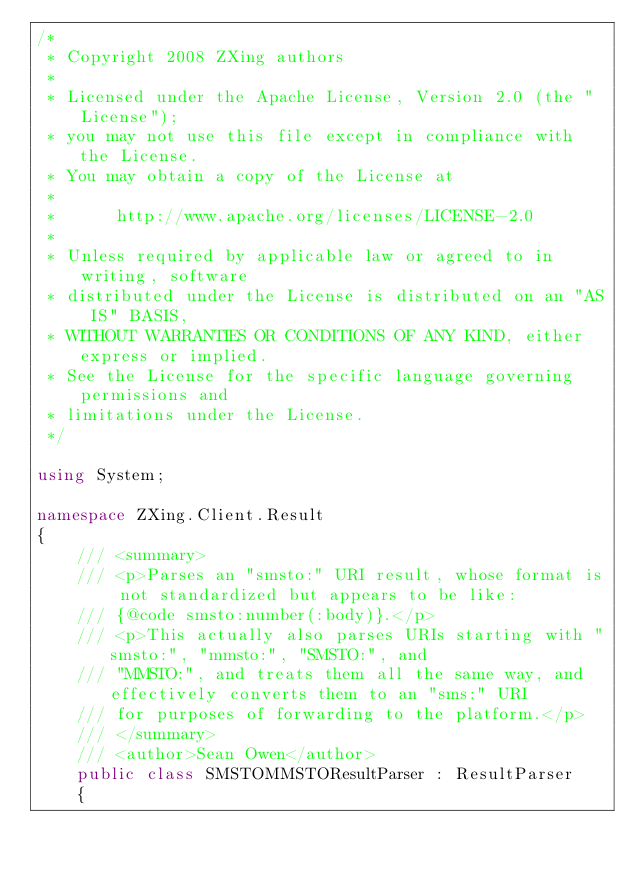Convert code to text. <code><loc_0><loc_0><loc_500><loc_500><_C#_>/*
 * Copyright 2008 ZXing authors
 *
 * Licensed under the Apache License, Version 2.0 (the "License");
 * you may not use this file except in compliance with the License.
 * You may obtain a copy of the License at
 *
 *      http://www.apache.org/licenses/LICENSE-2.0
 *
 * Unless required by applicable law or agreed to in writing, software
 * distributed under the License is distributed on an "AS IS" BASIS,
 * WITHOUT WARRANTIES OR CONDITIONS OF ANY KIND, either express or implied.
 * See the License for the specific language governing permissions and
 * limitations under the License.
 */

using System;

namespace ZXing.Client.Result
{
    /// <summary>
    /// <p>Parses an "smsto:" URI result, whose format is not standardized but appears to be like:
    /// {@code smsto:number(:body)}.</p>
    /// <p>This actually also parses URIs starting with "smsto:", "mmsto:", "SMSTO:", and
    /// "MMSTO:", and treats them all the same way, and effectively converts them to an "sms:" URI
    /// for purposes of forwarding to the platform.</p>
    /// </summary>
    /// <author>Sean Owen</author>
    public class SMSTOMMSTOResultParser : ResultParser
    {</code> 